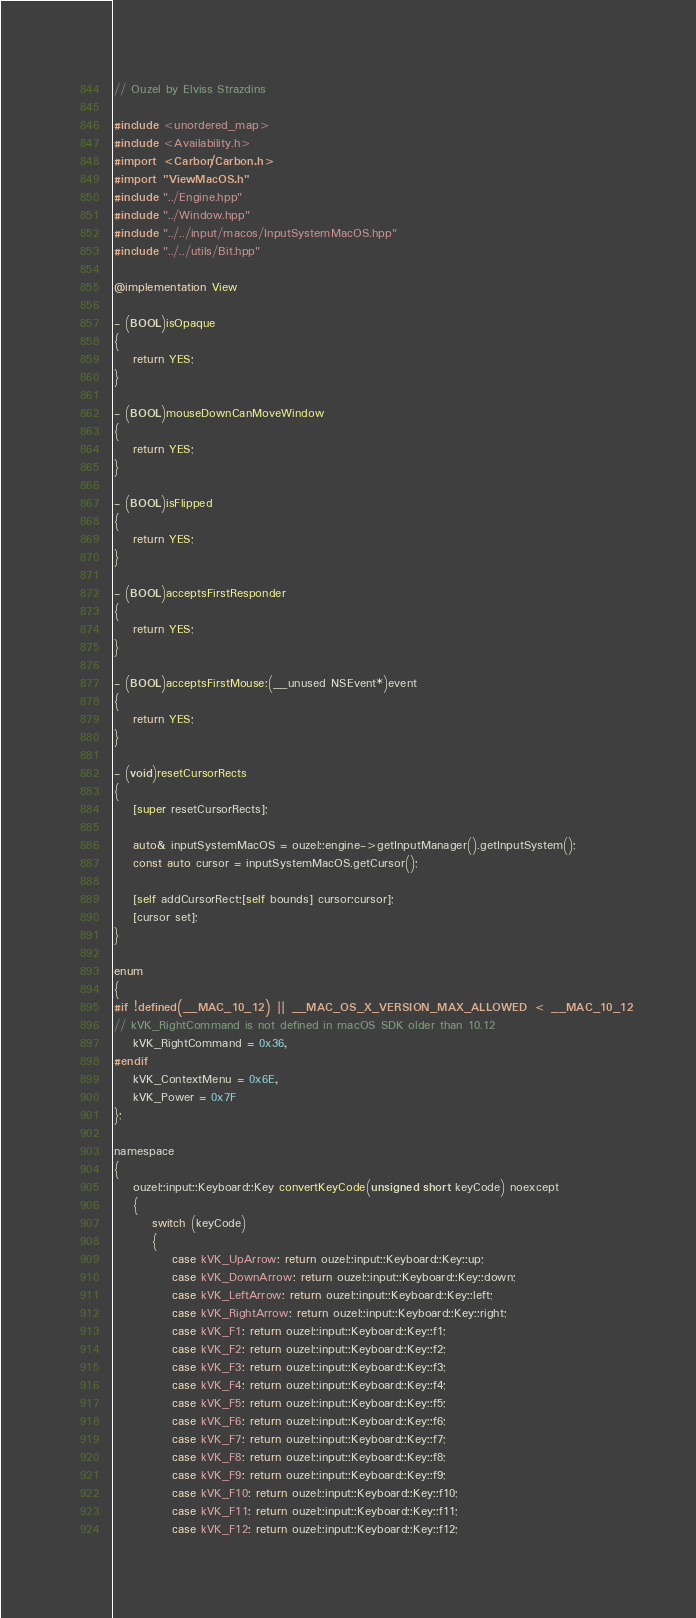<code> <loc_0><loc_0><loc_500><loc_500><_ObjectiveC_>// Ouzel by Elviss Strazdins

#include <unordered_map>
#include <Availability.h>
#import <Carbon/Carbon.h>
#import "ViewMacOS.h"
#include "../Engine.hpp"
#include "../Window.hpp"
#include "../../input/macos/InputSystemMacOS.hpp"
#include "../../utils/Bit.hpp"

@implementation View

- (BOOL)isOpaque
{
    return YES;
}

- (BOOL)mouseDownCanMoveWindow
{
    return YES;
}

- (BOOL)isFlipped
{
    return YES;
}

- (BOOL)acceptsFirstResponder
{
    return YES;
}

- (BOOL)acceptsFirstMouse:(__unused NSEvent*)event
{
    return YES;
}

- (void)resetCursorRects
{
    [super resetCursorRects];

    auto& inputSystemMacOS = ouzel::engine->getInputManager().getInputSystem();
    const auto cursor = inputSystemMacOS.getCursor();

    [self addCursorRect:[self bounds] cursor:cursor];
    [cursor set];
}

enum
{
#if !defined(__MAC_10_12) || __MAC_OS_X_VERSION_MAX_ALLOWED < __MAC_10_12
// kVK_RightCommand is not defined in macOS SDK older than 10.12
    kVK_RightCommand = 0x36,
#endif
    kVK_ContextMenu = 0x6E,
    kVK_Power = 0x7F
};

namespace
{
    ouzel::input::Keyboard::Key convertKeyCode(unsigned short keyCode) noexcept
    {
        switch (keyCode)
        {
            case kVK_UpArrow: return ouzel::input::Keyboard::Key::up;
            case kVK_DownArrow: return ouzel::input::Keyboard::Key::down;
            case kVK_LeftArrow: return ouzel::input::Keyboard::Key::left;
            case kVK_RightArrow: return ouzel::input::Keyboard::Key::right;
            case kVK_F1: return ouzel::input::Keyboard::Key::f1;
            case kVK_F2: return ouzel::input::Keyboard::Key::f2;
            case kVK_F3: return ouzel::input::Keyboard::Key::f3;
            case kVK_F4: return ouzel::input::Keyboard::Key::f4;
            case kVK_F5: return ouzel::input::Keyboard::Key::f5;
            case kVK_F6: return ouzel::input::Keyboard::Key::f6;
            case kVK_F7: return ouzel::input::Keyboard::Key::f7;
            case kVK_F8: return ouzel::input::Keyboard::Key::f8;
            case kVK_F9: return ouzel::input::Keyboard::Key::f9;
            case kVK_F10: return ouzel::input::Keyboard::Key::f10;
            case kVK_F11: return ouzel::input::Keyboard::Key::f11;
            case kVK_F12: return ouzel::input::Keyboard::Key::f12;</code> 